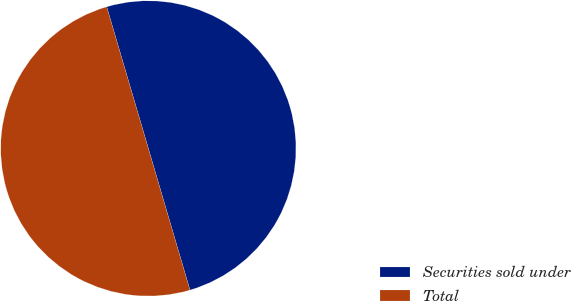Convert chart. <chart><loc_0><loc_0><loc_500><loc_500><pie_chart><fcel>Securities sold under<fcel>Total<nl><fcel>50.0%<fcel>50.0%<nl></chart> 